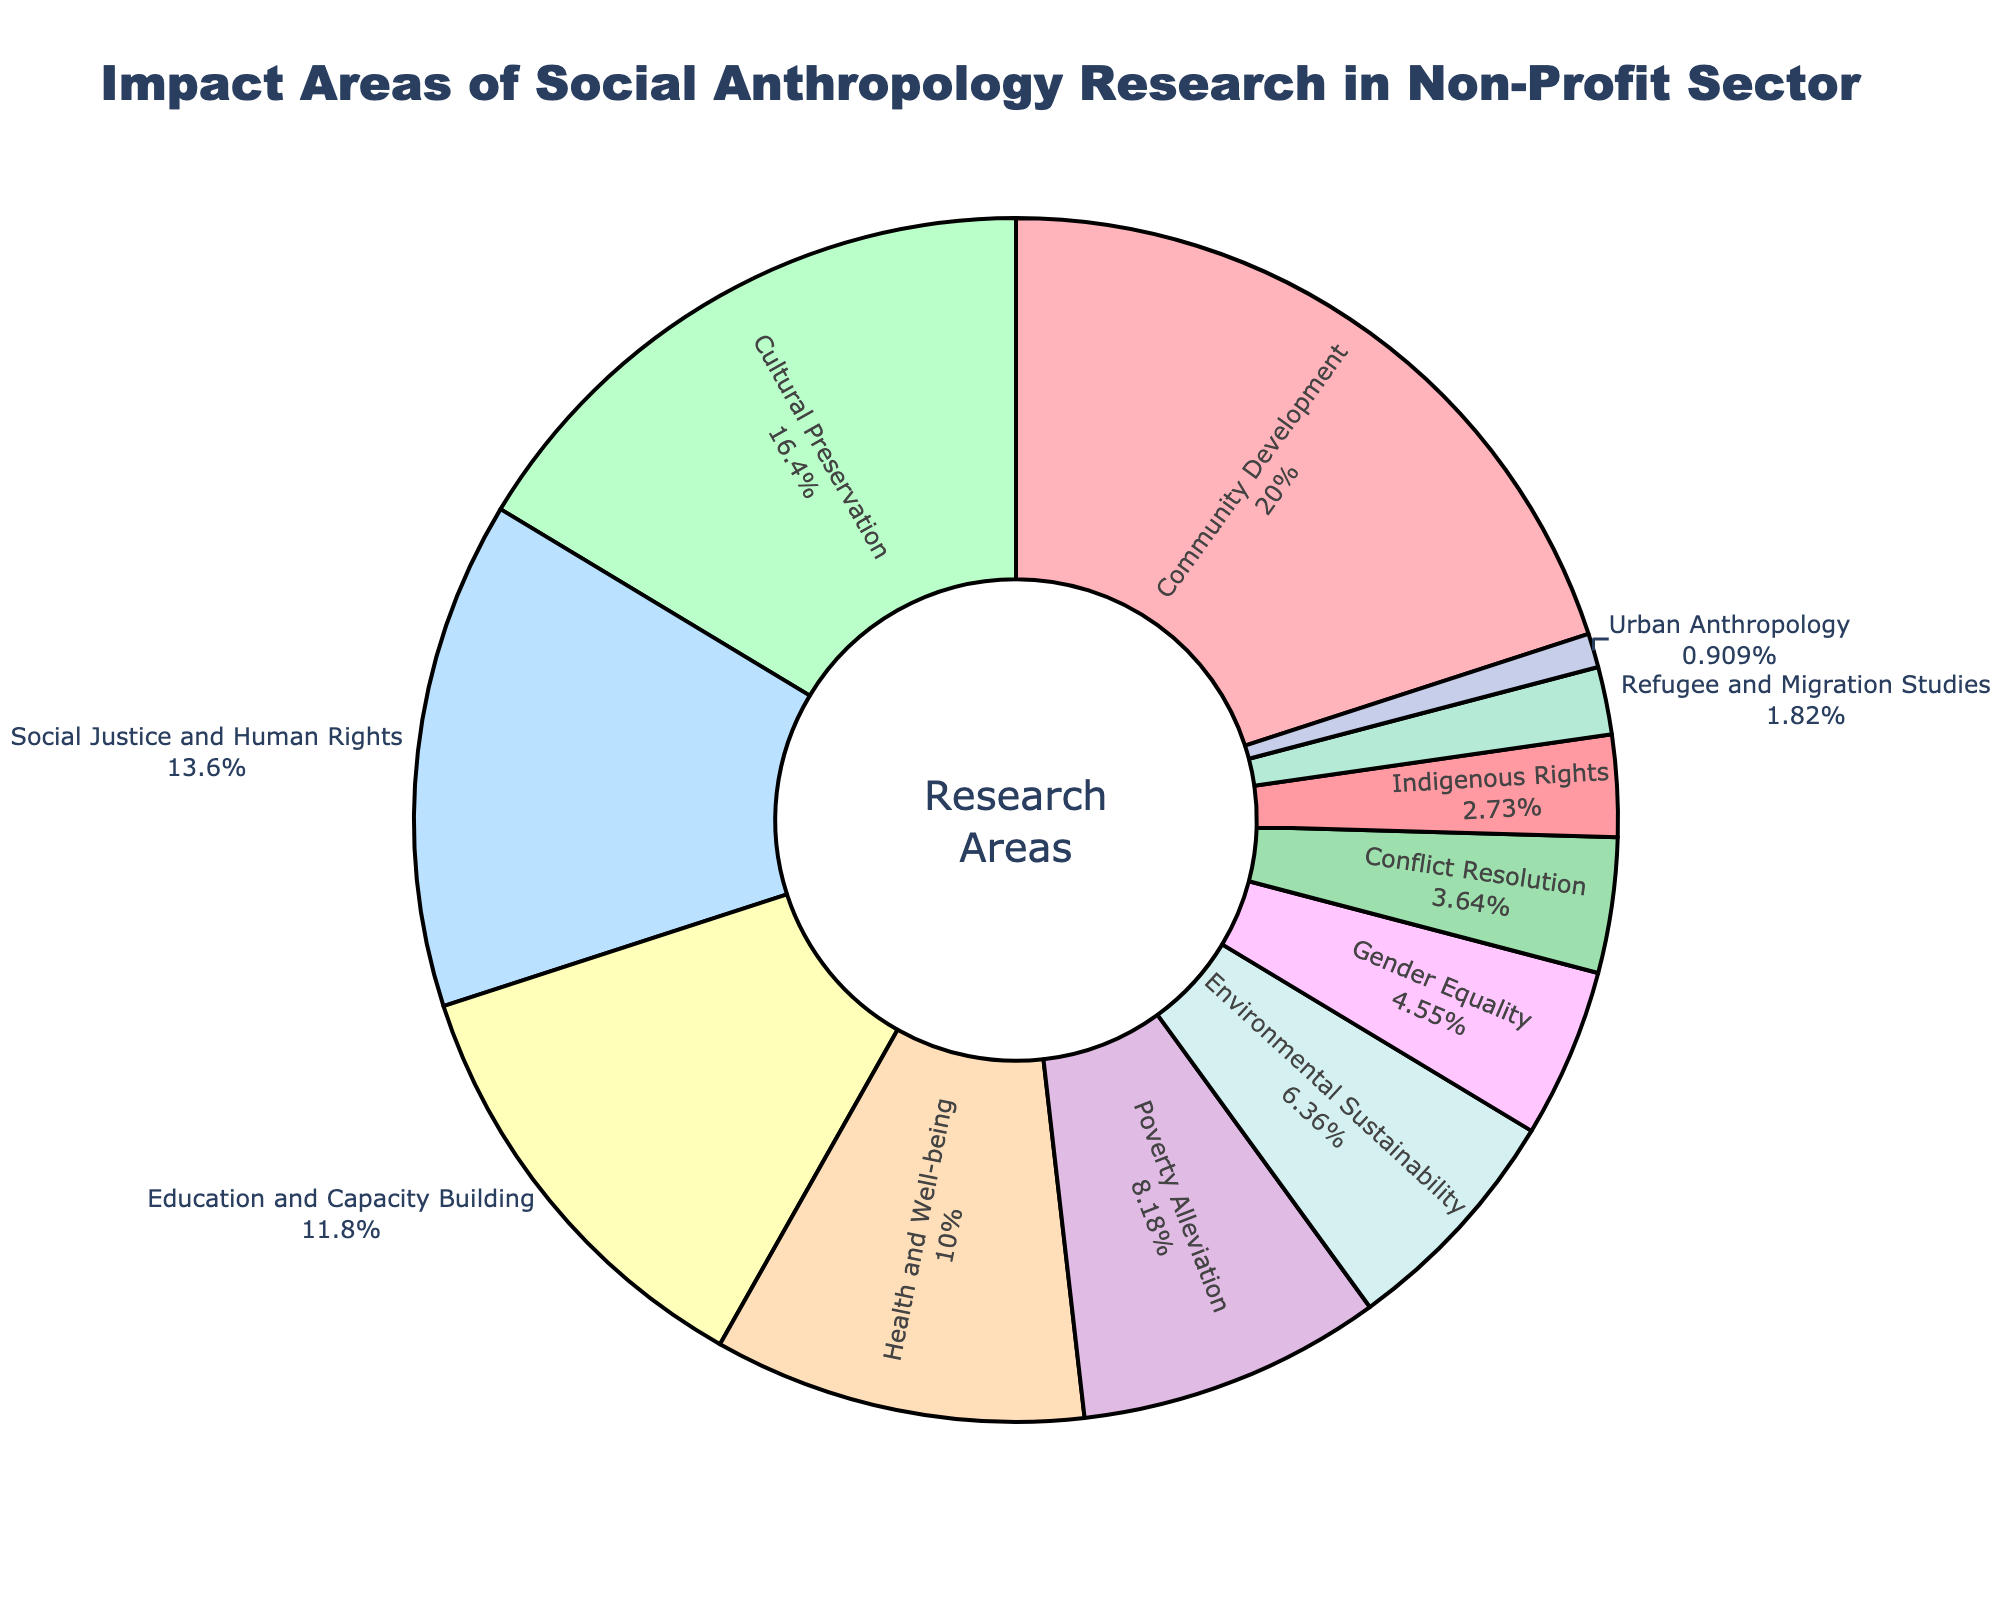What is the largest impact area of social anthropology research in the non-profit sector according to the pie chart? To find the largest impact area, we look at the segments in the pie chart and find the one with the greatest percentage. The "Community Development" segment has the largest share at 22%.
Answer: Community Development How much larger is the percentage of Cultural Preservation compared to Urban Anthropology? To find the difference, we subtract the percentage of Urban Anthropology (1%) from the percentage of Cultural Preservation (18%). This calculation is 18% - 1% = 17%.
Answer: 17% Which three impact areas together make up more than 50% of the total? Adding the three highest percentages together: Community Development (22%), Cultural Preservation (18%), and Social Justice and Human Rights (15%), we get 22% + 18% + 15% = 55%, which is more than 50%.
Answer: Community Development, Cultural Preservation, Social Justice and Human Rights What is the total percentage of the areas related to health and well-being (Health and Well-being and Poverty Alleviation)? Sum the percentages for Health and Well-being (11%) and Poverty Alleviation (9%): 11% + 9% = 20%.
Answer: 20% Which impact area has the smallest percentage in the pie chart? Look for the segment with the smallest percentage in the pie chart. The "Urban Anthropology" segment has the smallest percentage at 1%.
Answer: Urban Anthropology Is the percentage of Social Justice and Human Rights greater than the combined percentage of Refugee and Migration Studies and Gender Equality? Compare the percentage of Social Justice and Human Rights (15%) with the sum of Refugee and Migration Studies (2%) and Gender Equality (5%): 2% + 5% = 7%. Since 15% is greater than 7%, the answer is yes.
Answer: Yes How much of the entire pie chart is taken up by Environmental Sustainability, Gender Equality, and Conflict Resolution combined? Add the percentages of Environmental Sustainability (7%), Gender Equality (5%), and Conflict Resolution (4%): 7% + 5% + 4% = 16%.
Answer: 16% Which areas have percentages that are between 10% and 20%? Identify the segments whose percentages fall within the range of 10% to 20%. They are Cultural Preservation (18%), Social Justice and Human Rights (15%), Education and Capacity Building (13%), and Health and Well-being (11%).
Answer: Cultural Preservation, Social Justice and Human Rights, Education and Capacity Building, Health and Well-being If you combine the percentages of Indigenous Rights and Urban Anthropology, does it surpass the percentage of Poverty Alleviation? Sum the percentages for Indigenous Rights (3%) and Urban Anthropology (1%): 3% + 1% = 4%. Since 4% is not greater than 9%, the answer is no.
Answer: No 